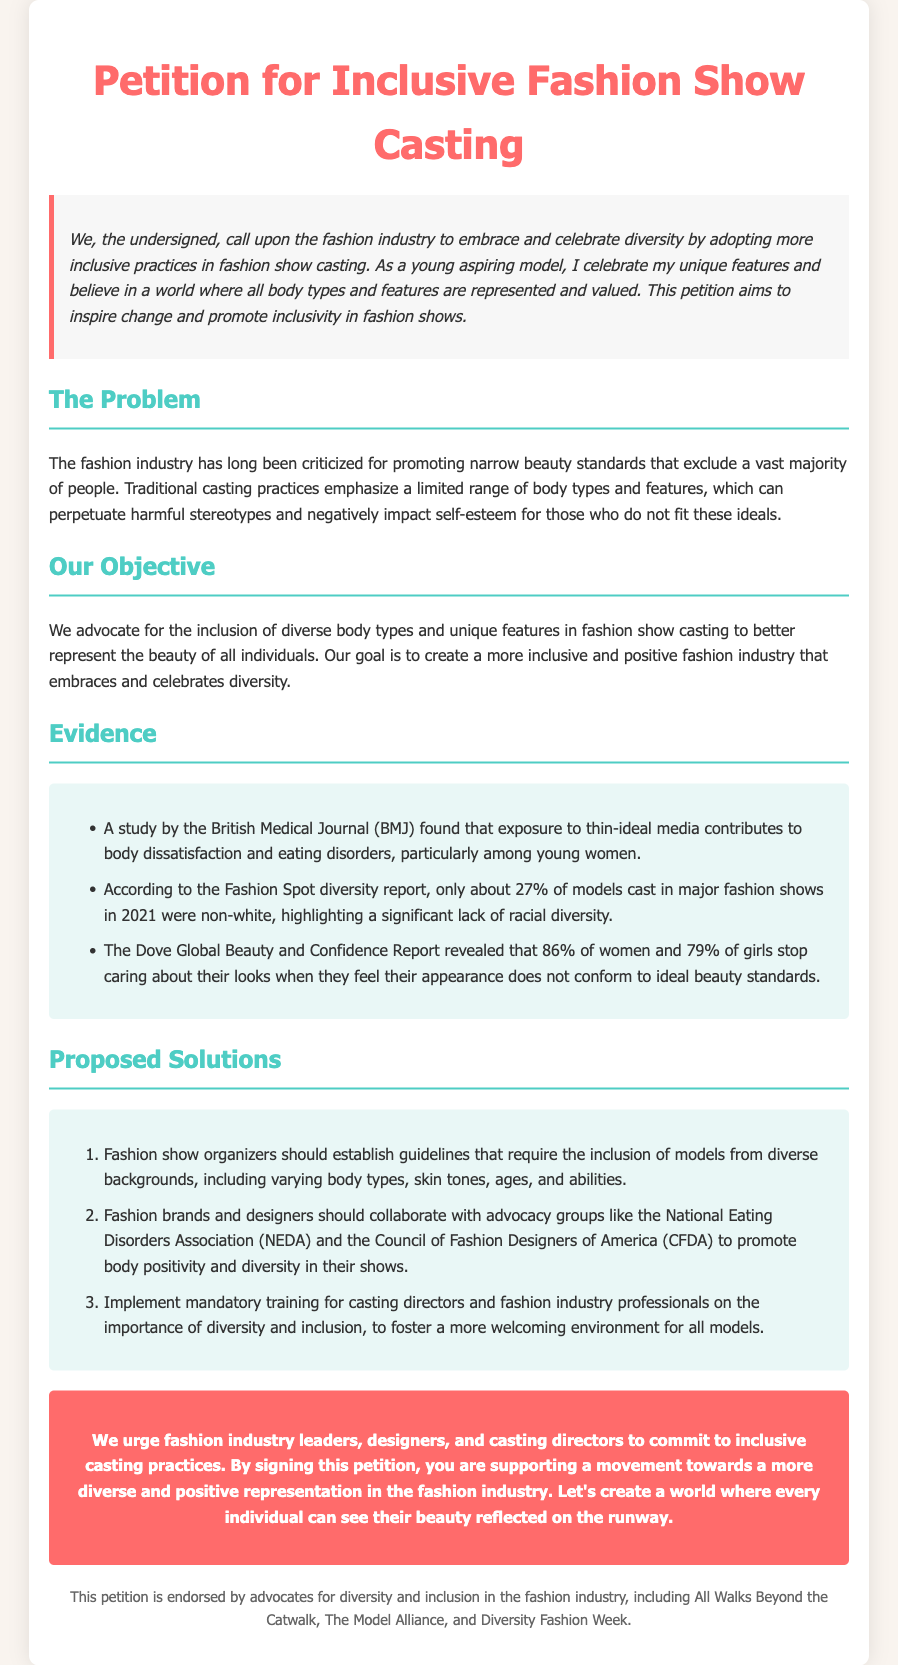What is the title of the petition? The title of the petition is clearly stated at the top of the document.
Answer: Petition for Inclusive Fashion Show Casting What percentage of models cast in major fashion shows in 2021 were non-white? The document provides statistics regarding racial diversity in the fashion industry.
Answer: 27% Who conducted the study on thin-ideal media? The document cites a reputable source for the study.
Answer: British Medical Journal (BMJ) What is one proposed solution for improving casting diversity? The document lists several proposed solutions aimed at promoting diversity in fashion show casting.
Answer: Establish guidelines for inclusion What group is mentioned as a collaborator to promote body positivity? The document highlights specific advocacy groups that could help in promoting diversity.
Answer: National Eating Disorders Association (NEDA) What issue does the fashion industry face according to the petition? The document discusses the main problem related to beauty standards in the fashion industry.
Answer: Narrow beauty standards What is the objective stated in the petition? The objective of the petition is defined in a specific section of the document.
Answer: Inclusion of diverse body types What organization is mentioned as an endorser of the petition? The document lists several endorsers that support diversity in the fashion industry.
Answer: All Walks Beyond the Catwalk 